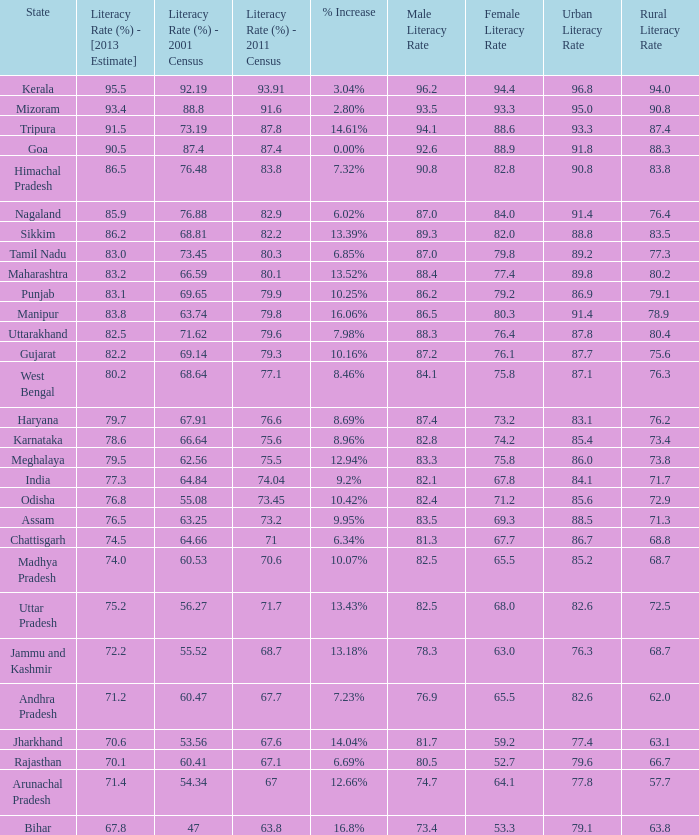What is the average estimated 2013 literacy rate for the states that had a literacy rate of 68.81% in the 2001 census and a literacy rate higher than 79.6% in the 2011 census? 86.2. 